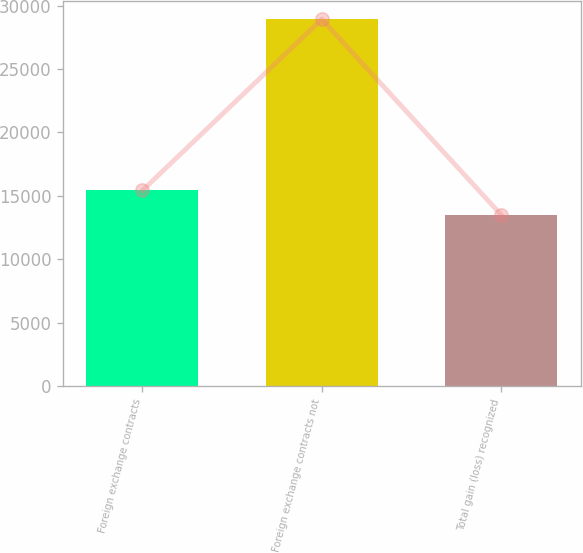<chart> <loc_0><loc_0><loc_500><loc_500><bar_chart><fcel>Foreign exchange contracts<fcel>Foreign exchange contracts not<fcel>Total gain (loss) recognized<nl><fcel>15430<fcel>28933<fcel>13503<nl></chart> 